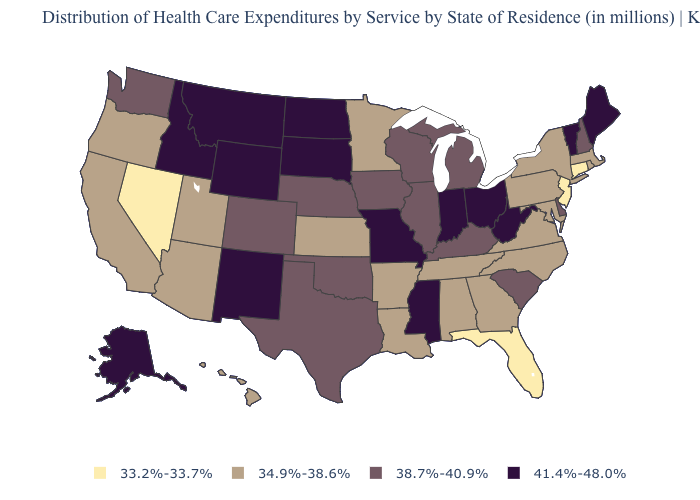What is the highest value in the South ?
Short answer required. 41.4%-48.0%. Name the states that have a value in the range 33.2%-33.7%?
Give a very brief answer. Connecticut, Florida, Nevada, New Jersey. Among the states that border Wyoming , which have the lowest value?
Keep it brief. Utah. Does the map have missing data?
Short answer required. No. Name the states that have a value in the range 38.7%-40.9%?
Write a very short answer. Colorado, Delaware, Illinois, Iowa, Kentucky, Michigan, Nebraska, New Hampshire, Oklahoma, South Carolina, Texas, Washington, Wisconsin. Name the states that have a value in the range 38.7%-40.9%?
Keep it brief. Colorado, Delaware, Illinois, Iowa, Kentucky, Michigan, Nebraska, New Hampshire, Oklahoma, South Carolina, Texas, Washington, Wisconsin. What is the value of Florida?
Quick response, please. 33.2%-33.7%. Does Idaho have the highest value in the USA?
Give a very brief answer. Yes. Among the states that border Indiana , which have the lowest value?
Give a very brief answer. Illinois, Kentucky, Michigan. Is the legend a continuous bar?
Answer briefly. No. Name the states that have a value in the range 41.4%-48.0%?
Short answer required. Alaska, Idaho, Indiana, Maine, Mississippi, Missouri, Montana, New Mexico, North Dakota, Ohio, South Dakota, Vermont, West Virginia, Wyoming. What is the highest value in the USA?
Keep it brief. 41.4%-48.0%. What is the highest value in the South ?
Concise answer only. 41.4%-48.0%. What is the value of Montana?
Keep it brief. 41.4%-48.0%. What is the value of Utah?
Quick response, please. 34.9%-38.6%. 